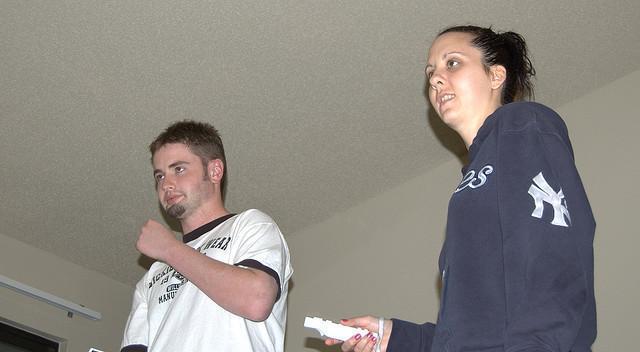How many people are sitting down?
Give a very brief answer. 0. How many men are here?
Give a very brief answer. 1. How many shirts is the man on the left wearing?
Give a very brief answer. 1. How many people are in the photo?
Give a very brief answer. 2. How many of the boats in the front have yellow poles?
Give a very brief answer. 0. 